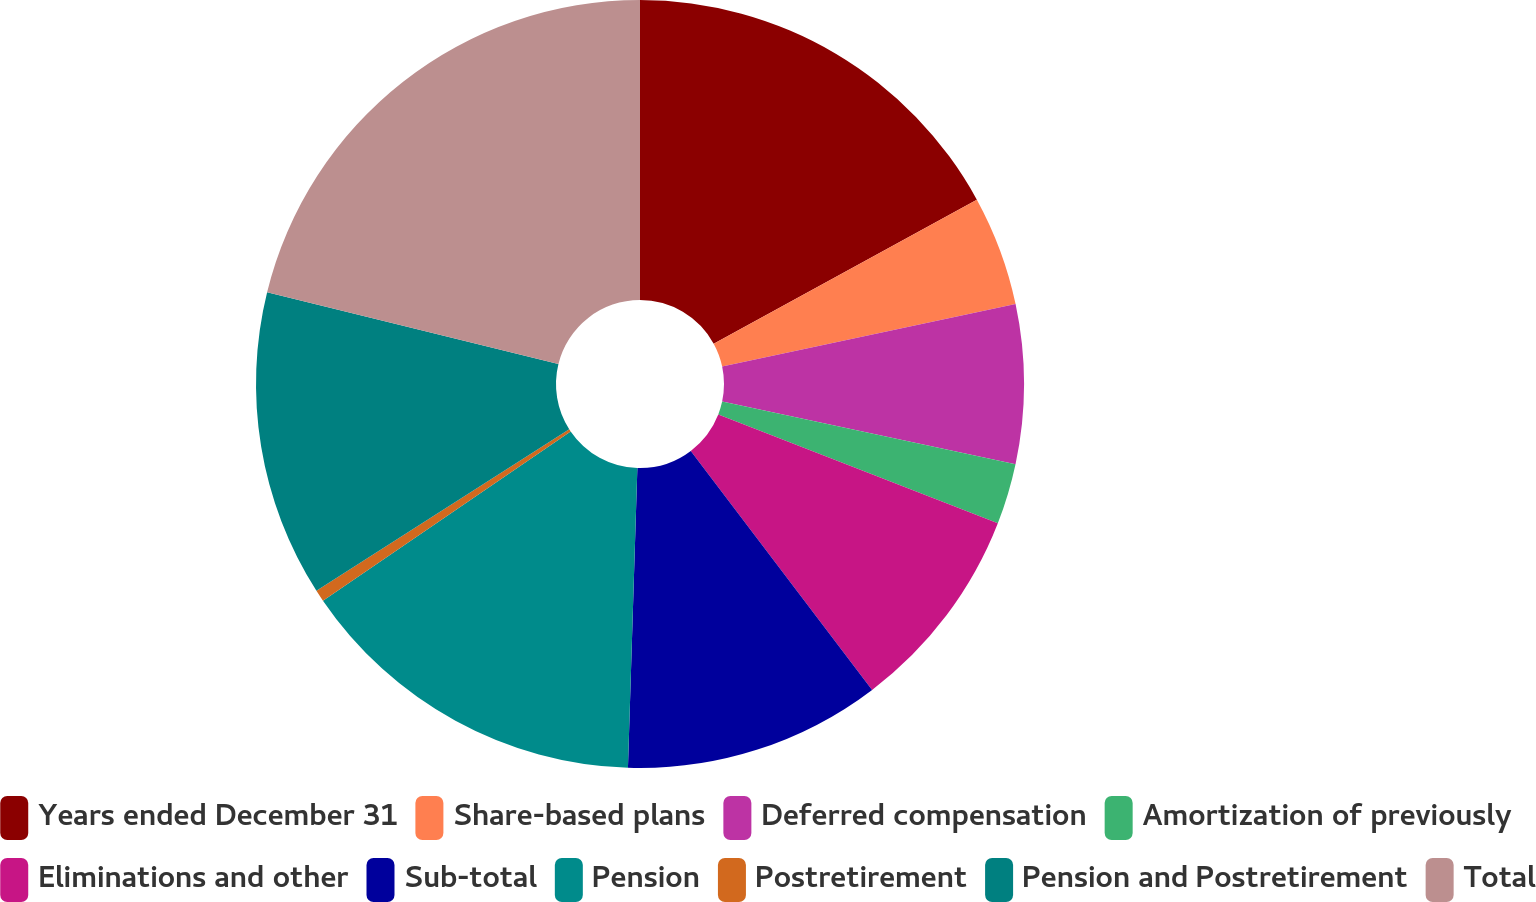Convert chart to OTSL. <chart><loc_0><loc_0><loc_500><loc_500><pie_chart><fcel>Years ended December 31<fcel>Share-based plans<fcel>Deferred compensation<fcel>Amortization of previously<fcel>Eliminations and other<fcel>Sub-total<fcel>Pension<fcel>Postretirement<fcel>Pension and Postretirement<fcel>Total<nl><fcel>17.03%<fcel>4.63%<fcel>6.69%<fcel>2.56%<fcel>8.76%<fcel>10.83%<fcel>14.96%<fcel>0.49%<fcel>12.89%<fcel>21.16%<nl></chart> 